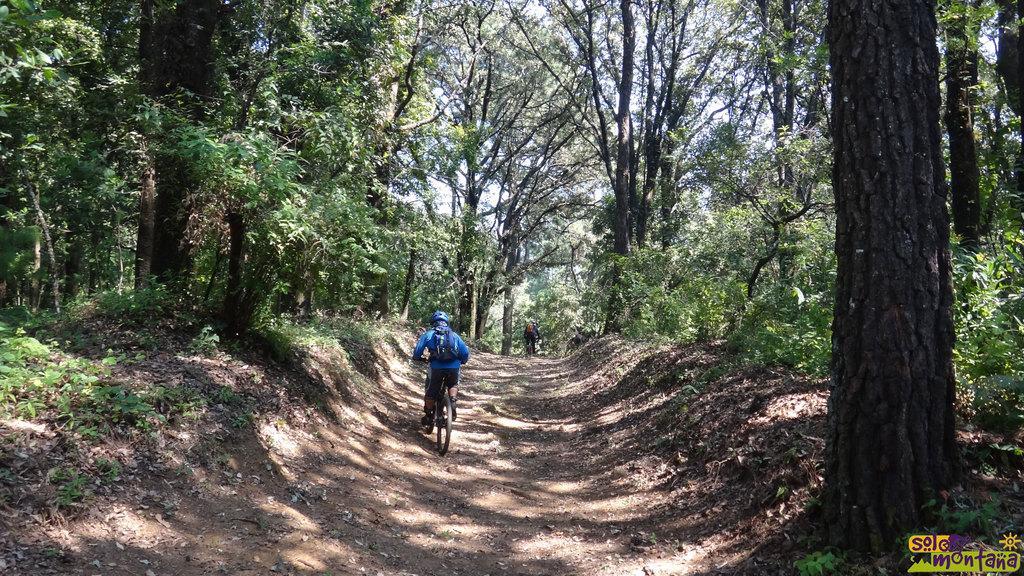How would you summarize this image in a sentence or two? In this picture we can see two persons riding on bicycles and in the background we can see trees,sky. 